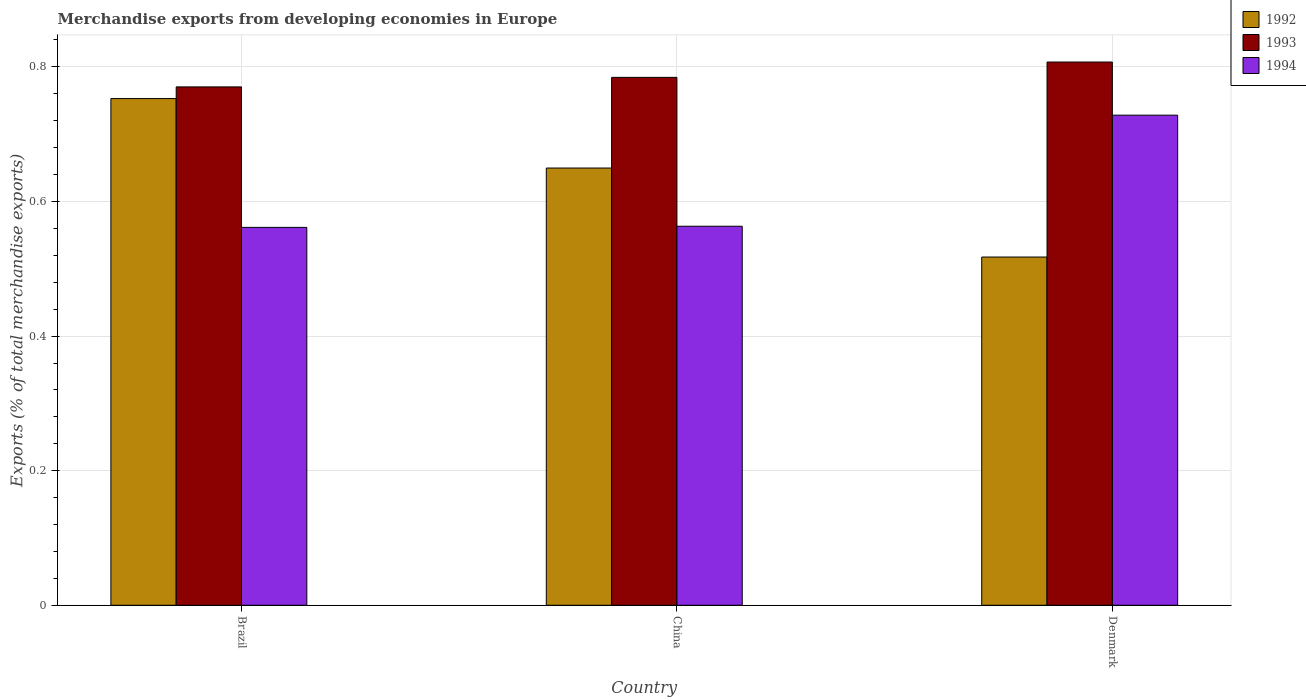How many different coloured bars are there?
Ensure brevity in your answer.  3. How many groups of bars are there?
Ensure brevity in your answer.  3. Are the number of bars on each tick of the X-axis equal?
Keep it short and to the point. Yes. How many bars are there on the 3rd tick from the right?
Provide a succinct answer. 3. What is the label of the 3rd group of bars from the left?
Make the answer very short. Denmark. What is the percentage of total merchandise exports in 1992 in Denmark?
Give a very brief answer. 0.52. Across all countries, what is the maximum percentage of total merchandise exports in 1994?
Your response must be concise. 0.73. Across all countries, what is the minimum percentage of total merchandise exports in 1992?
Make the answer very short. 0.52. In which country was the percentage of total merchandise exports in 1992 maximum?
Your response must be concise. Brazil. What is the total percentage of total merchandise exports in 1993 in the graph?
Your response must be concise. 2.36. What is the difference between the percentage of total merchandise exports in 1993 in China and that in Denmark?
Your answer should be compact. -0.02. What is the difference between the percentage of total merchandise exports in 1992 in Brazil and the percentage of total merchandise exports in 1993 in China?
Keep it short and to the point. -0.03. What is the average percentage of total merchandise exports in 1992 per country?
Your answer should be very brief. 0.64. What is the difference between the percentage of total merchandise exports of/in 1994 and percentage of total merchandise exports of/in 1992 in Brazil?
Offer a terse response. -0.19. What is the ratio of the percentage of total merchandise exports in 1992 in Brazil to that in China?
Your answer should be very brief. 1.16. Is the percentage of total merchandise exports in 1993 in China less than that in Denmark?
Provide a succinct answer. Yes. What is the difference between the highest and the second highest percentage of total merchandise exports in 1994?
Make the answer very short. 0.17. What is the difference between the highest and the lowest percentage of total merchandise exports in 1992?
Ensure brevity in your answer.  0.24. Is the sum of the percentage of total merchandise exports in 1993 in Brazil and China greater than the maximum percentage of total merchandise exports in 1994 across all countries?
Your response must be concise. Yes. Is it the case that in every country, the sum of the percentage of total merchandise exports in 1992 and percentage of total merchandise exports in 1994 is greater than the percentage of total merchandise exports in 1993?
Your answer should be compact. Yes. How many bars are there?
Your answer should be compact. 9. What is the difference between two consecutive major ticks on the Y-axis?
Provide a short and direct response. 0.2. Are the values on the major ticks of Y-axis written in scientific E-notation?
Offer a terse response. No. Does the graph contain any zero values?
Offer a terse response. No. Does the graph contain grids?
Your response must be concise. Yes. Where does the legend appear in the graph?
Provide a short and direct response. Top right. How are the legend labels stacked?
Make the answer very short. Vertical. What is the title of the graph?
Your response must be concise. Merchandise exports from developing economies in Europe. What is the label or title of the X-axis?
Give a very brief answer. Country. What is the label or title of the Y-axis?
Provide a short and direct response. Exports (% of total merchandise exports). What is the Exports (% of total merchandise exports) of 1992 in Brazil?
Your answer should be compact. 0.75. What is the Exports (% of total merchandise exports) in 1993 in Brazil?
Ensure brevity in your answer.  0.77. What is the Exports (% of total merchandise exports) in 1994 in Brazil?
Provide a succinct answer. 0.56. What is the Exports (% of total merchandise exports) of 1992 in China?
Offer a very short reply. 0.65. What is the Exports (% of total merchandise exports) in 1993 in China?
Keep it short and to the point. 0.78. What is the Exports (% of total merchandise exports) in 1994 in China?
Your response must be concise. 0.56. What is the Exports (% of total merchandise exports) of 1992 in Denmark?
Your answer should be compact. 0.52. What is the Exports (% of total merchandise exports) in 1993 in Denmark?
Make the answer very short. 0.81. What is the Exports (% of total merchandise exports) in 1994 in Denmark?
Your answer should be very brief. 0.73. Across all countries, what is the maximum Exports (% of total merchandise exports) of 1992?
Provide a succinct answer. 0.75. Across all countries, what is the maximum Exports (% of total merchandise exports) of 1993?
Provide a short and direct response. 0.81. Across all countries, what is the maximum Exports (% of total merchandise exports) of 1994?
Offer a terse response. 0.73. Across all countries, what is the minimum Exports (% of total merchandise exports) of 1992?
Provide a short and direct response. 0.52. Across all countries, what is the minimum Exports (% of total merchandise exports) in 1993?
Provide a short and direct response. 0.77. Across all countries, what is the minimum Exports (% of total merchandise exports) in 1994?
Your answer should be very brief. 0.56. What is the total Exports (% of total merchandise exports) in 1992 in the graph?
Provide a short and direct response. 1.92. What is the total Exports (% of total merchandise exports) of 1993 in the graph?
Your response must be concise. 2.36. What is the total Exports (% of total merchandise exports) in 1994 in the graph?
Offer a very short reply. 1.85. What is the difference between the Exports (% of total merchandise exports) of 1992 in Brazil and that in China?
Offer a very short reply. 0.1. What is the difference between the Exports (% of total merchandise exports) of 1993 in Brazil and that in China?
Ensure brevity in your answer.  -0.01. What is the difference between the Exports (% of total merchandise exports) of 1994 in Brazil and that in China?
Make the answer very short. -0. What is the difference between the Exports (% of total merchandise exports) in 1992 in Brazil and that in Denmark?
Make the answer very short. 0.24. What is the difference between the Exports (% of total merchandise exports) in 1993 in Brazil and that in Denmark?
Provide a short and direct response. -0.04. What is the difference between the Exports (% of total merchandise exports) of 1994 in Brazil and that in Denmark?
Provide a succinct answer. -0.17. What is the difference between the Exports (% of total merchandise exports) in 1992 in China and that in Denmark?
Ensure brevity in your answer.  0.13. What is the difference between the Exports (% of total merchandise exports) in 1993 in China and that in Denmark?
Give a very brief answer. -0.02. What is the difference between the Exports (% of total merchandise exports) of 1994 in China and that in Denmark?
Your answer should be very brief. -0.17. What is the difference between the Exports (% of total merchandise exports) in 1992 in Brazil and the Exports (% of total merchandise exports) in 1993 in China?
Make the answer very short. -0.03. What is the difference between the Exports (% of total merchandise exports) of 1992 in Brazil and the Exports (% of total merchandise exports) of 1994 in China?
Ensure brevity in your answer.  0.19. What is the difference between the Exports (% of total merchandise exports) in 1993 in Brazil and the Exports (% of total merchandise exports) in 1994 in China?
Your answer should be very brief. 0.21. What is the difference between the Exports (% of total merchandise exports) in 1992 in Brazil and the Exports (% of total merchandise exports) in 1993 in Denmark?
Make the answer very short. -0.05. What is the difference between the Exports (% of total merchandise exports) of 1992 in Brazil and the Exports (% of total merchandise exports) of 1994 in Denmark?
Make the answer very short. 0.02. What is the difference between the Exports (% of total merchandise exports) in 1993 in Brazil and the Exports (% of total merchandise exports) in 1994 in Denmark?
Give a very brief answer. 0.04. What is the difference between the Exports (% of total merchandise exports) of 1992 in China and the Exports (% of total merchandise exports) of 1993 in Denmark?
Make the answer very short. -0.16. What is the difference between the Exports (% of total merchandise exports) of 1992 in China and the Exports (% of total merchandise exports) of 1994 in Denmark?
Provide a short and direct response. -0.08. What is the difference between the Exports (% of total merchandise exports) of 1993 in China and the Exports (% of total merchandise exports) of 1994 in Denmark?
Your response must be concise. 0.06. What is the average Exports (% of total merchandise exports) of 1992 per country?
Provide a succinct answer. 0.64. What is the average Exports (% of total merchandise exports) in 1993 per country?
Give a very brief answer. 0.79. What is the average Exports (% of total merchandise exports) in 1994 per country?
Your answer should be very brief. 0.62. What is the difference between the Exports (% of total merchandise exports) of 1992 and Exports (% of total merchandise exports) of 1993 in Brazil?
Provide a succinct answer. -0.02. What is the difference between the Exports (% of total merchandise exports) in 1992 and Exports (% of total merchandise exports) in 1994 in Brazil?
Your response must be concise. 0.19. What is the difference between the Exports (% of total merchandise exports) in 1993 and Exports (% of total merchandise exports) in 1994 in Brazil?
Keep it short and to the point. 0.21. What is the difference between the Exports (% of total merchandise exports) in 1992 and Exports (% of total merchandise exports) in 1993 in China?
Ensure brevity in your answer.  -0.13. What is the difference between the Exports (% of total merchandise exports) of 1992 and Exports (% of total merchandise exports) of 1994 in China?
Make the answer very short. 0.09. What is the difference between the Exports (% of total merchandise exports) of 1993 and Exports (% of total merchandise exports) of 1994 in China?
Offer a very short reply. 0.22. What is the difference between the Exports (% of total merchandise exports) of 1992 and Exports (% of total merchandise exports) of 1993 in Denmark?
Your response must be concise. -0.29. What is the difference between the Exports (% of total merchandise exports) in 1992 and Exports (% of total merchandise exports) in 1994 in Denmark?
Make the answer very short. -0.21. What is the difference between the Exports (% of total merchandise exports) in 1993 and Exports (% of total merchandise exports) in 1994 in Denmark?
Make the answer very short. 0.08. What is the ratio of the Exports (% of total merchandise exports) in 1992 in Brazil to that in China?
Your answer should be compact. 1.16. What is the ratio of the Exports (% of total merchandise exports) of 1993 in Brazil to that in China?
Your answer should be compact. 0.98. What is the ratio of the Exports (% of total merchandise exports) in 1992 in Brazil to that in Denmark?
Make the answer very short. 1.46. What is the ratio of the Exports (% of total merchandise exports) of 1993 in Brazil to that in Denmark?
Your answer should be compact. 0.95. What is the ratio of the Exports (% of total merchandise exports) in 1994 in Brazil to that in Denmark?
Keep it short and to the point. 0.77. What is the ratio of the Exports (% of total merchandise exports) of 1992 in China to that in Denmark?
Provide a short and direct response. 1.26. What is the ratio of the Exports (% of total merchandise exports) in 1993 in China to that in Denmark?
Offer a very short reply. 0.97. What is the ratio of the Exports (% of total merchandise exports) in 1994 in China to that in Denmark?
Make the answer very short. 0.77. What is the difference between the highest and the second highest Exports (% of total merchandise exports) in 1992?
Make the answer very short. 0.1. What is the difference between the highest and the second highest Exports (% of total merchandise exports) of 1993?
Offer a very short reply. 0.02. What is the difference between the highest and the second highest Exports (% of total merchandise exports) of 1994?
Ensure brevity in your answer.  0.17. What is the difference between the highest and the lowest Exports (% of total merchandise exports) of 1992?
Your answer should be very brief. 0.24. What is the difference between the highest and the lowest Exports (% of total merchandise exports) of 1993?
Ensure brevity in your answer.  0.04. What is the difference between the highest and the lowest Exports (% of total merchandise exports) in 1994?
Offer a terse response. 0.17. 